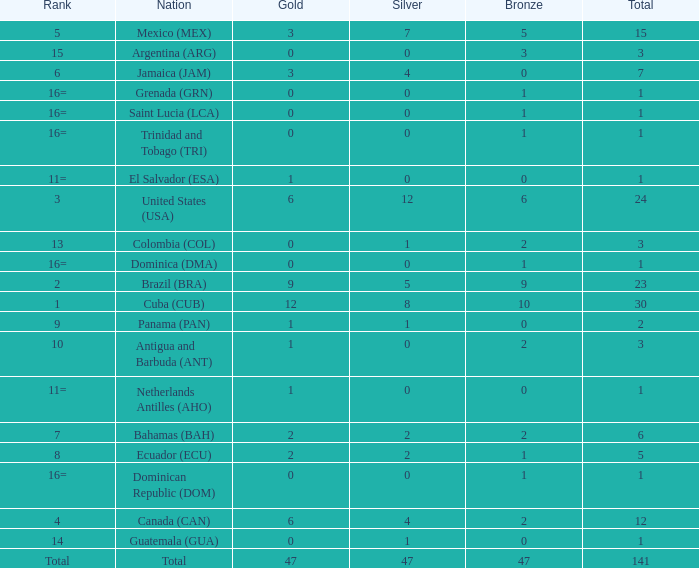What is the average silver with more than 0 gold, a Rank of 1, and a Total smaller than 30? None. 